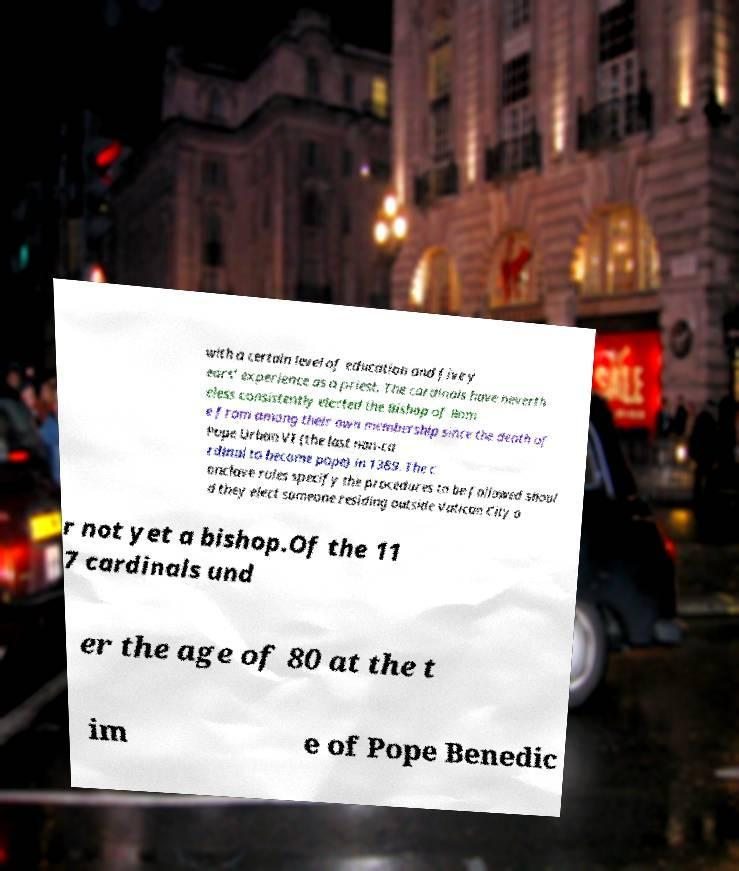For documentation purposes, I need the text within this image transcribed. Could you provide that? with a certain level of education and five y ears' experience as a priest. The cardinals have neverth eless consistently elected the Bishop of Rom e from among their own membership since the death of Pope Urban VI (the last non-ca rdinal to become pope) in 1389. The c onclave rules specify the procedures to be followed shoul d they elect someone residing outside Vatican City o r not yet a bishop.Of the 11 7 cardinals und er the age of 80 at the t im e of Pope Benedic 